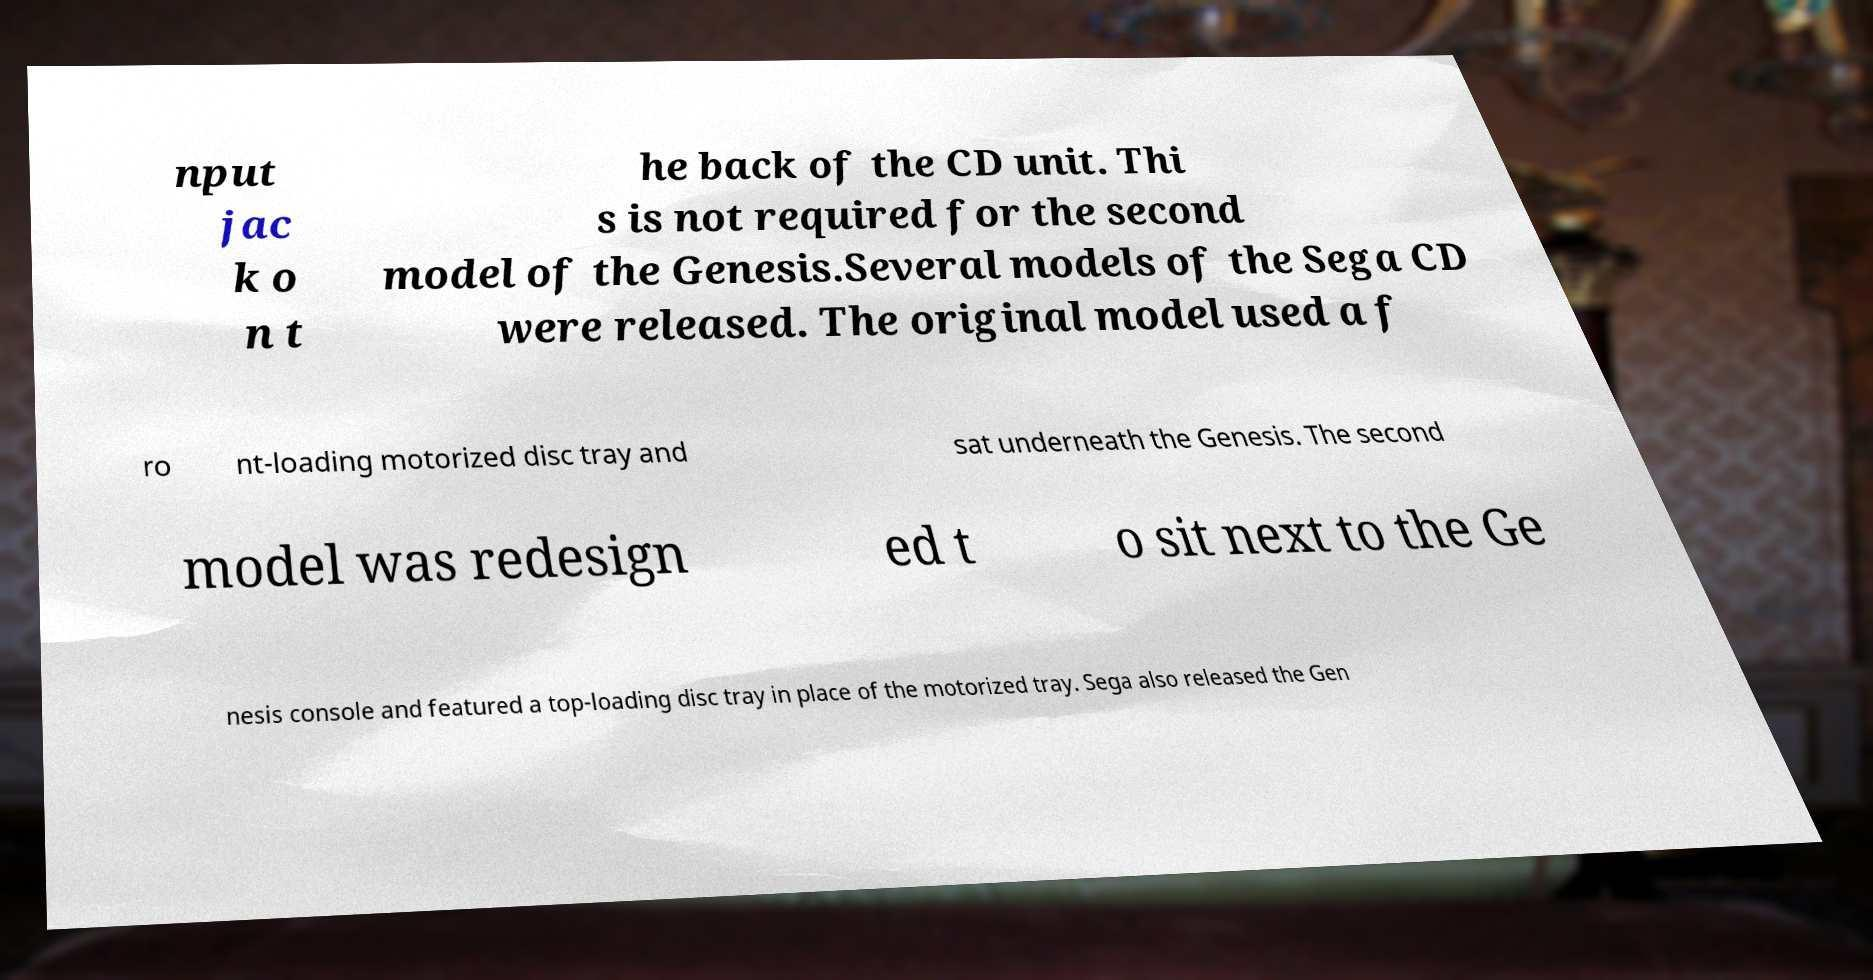For documentation purposes, I need the text within this image transcribed. Could you provide that? nput jac k o n t he back of the CD unit. Thi s is not required for the second model of the Genesis.Several models of the Sega CD were released. The original model used a f ro nt-loading motorized disc tray and sat underneath the Genesis. The second model was redesign ed t o sit next to the Ge nesis console and featured a top-loading disc tray in place of the motorized tray. Sega also released the Gen 